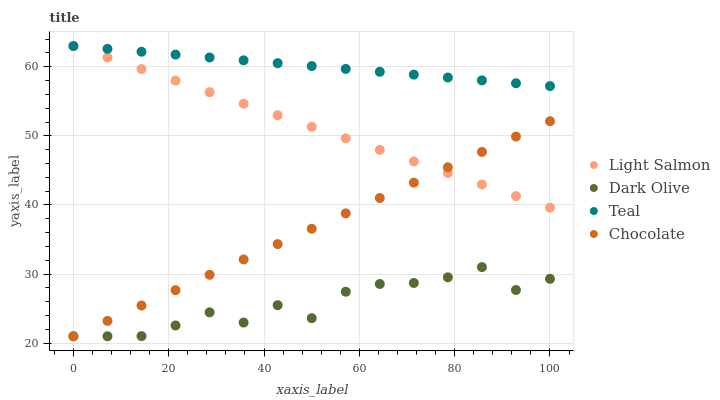Does Dark Olive have the minimum area under the curve?
Answer yes or no. Yes. Does Teal have the maximum area under the curve?
Answer yes or no. Yes. Does Teal have the minimum area under the curve?
Answer yes or no. No. Does Dark Olive have the maximum area under the curve?
Answer yes or no. No. Is Teal the smoothest?
Answer yes or no. Yes. Is Dark Olive the roughest?
Answer yes or no. Yes. Is Dark Olive the smoothest?
Answer yes or no. No. Is Teal the roughest?
Answer yes or no. No. Does Dark Olive have the lowest value?
Answer yes or no. Yes. Does Teal have the lowest value?
Answer yes or no. No. Does Teal have the highest value?
Answer yes or no. Yes. Does Dark Olive have the highest value?
Answer yes or no. No. Is Dark Olive less than Teal?
Answer yes or no. Yes. Is Teal greater than Chocolate?
Answer yes or no. Yes. Does Chocolate intersect Dark Olive?
Answer yes or no. Yes. Is Chocolate less than Dark Olive?
Answer yes or no. No. Is Chocolate greater than Dark Olive?
Answer yes or no. No. Does Dark Olive intersect Teal?
Answer yes or no. No. 